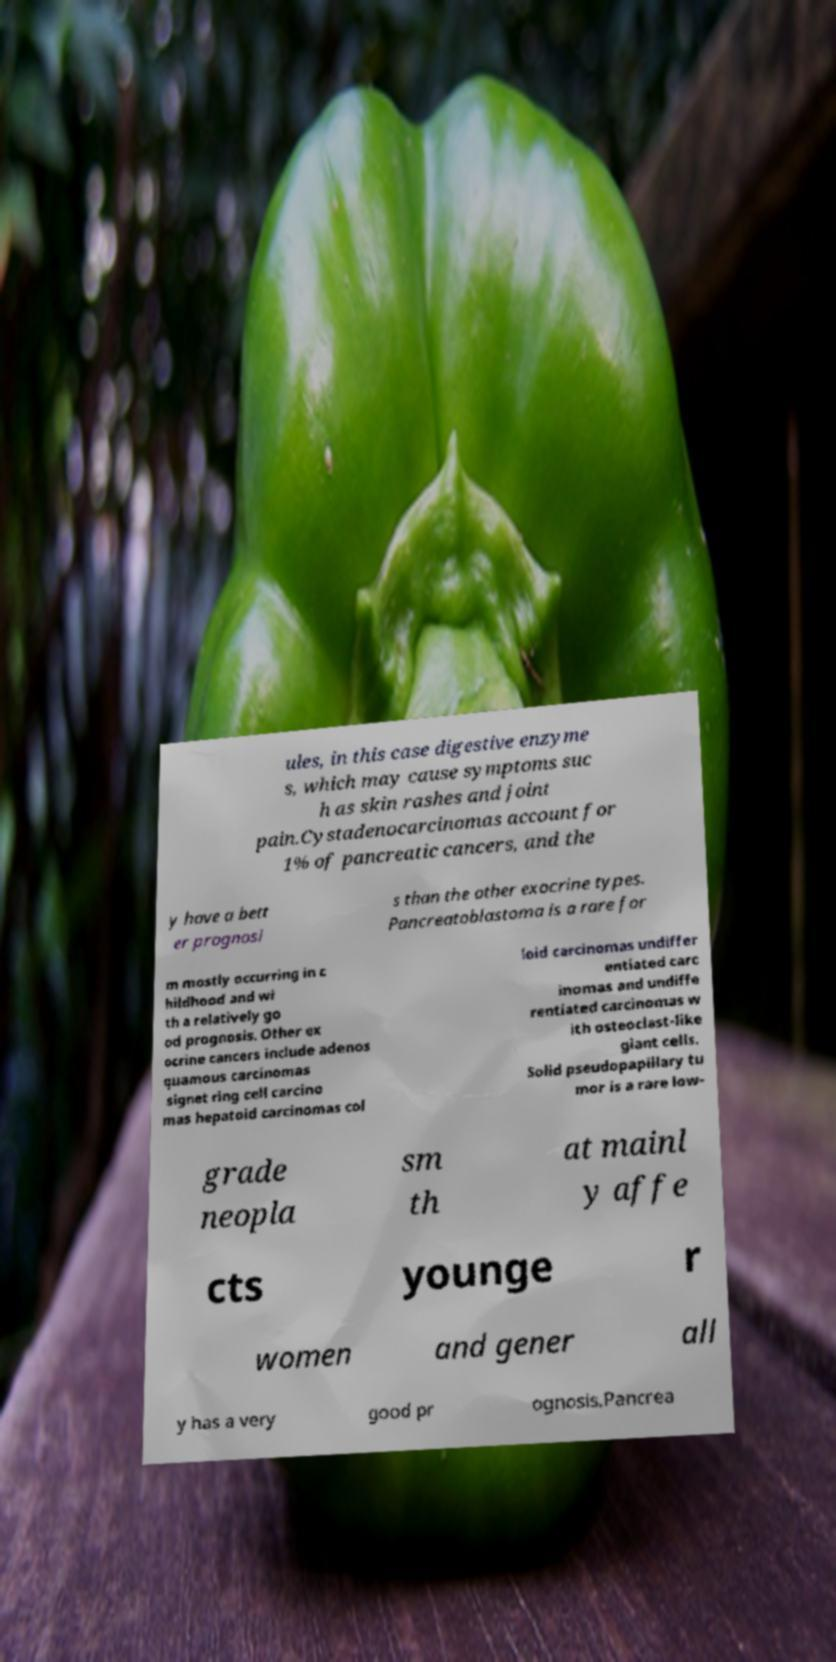Can you read and provide the text displayed in the image?This photo seems to have some interesting text. Can you extract and type it out for me? ules, in this case digestive enzyme s, which may cause symptoms suc h as skin rashes and joint pain.Cystadenocarcinomas account for 1% of pancreatic cancers, and the y have a bett er prognosi s than the other exocrine types. Pancreatoblastoma is a rare for m mostly occurring in c hildhood and wi th a relatively go od prognosis. Other ex ocrine cancers include adenos quamous carcinomas signet ring cell carcino mas hepatoid carcinomas col loid carcinomas undiffer entiated carc inomas and undiffe rentiated carcinomas w ith osteoclast-like giant cells. Solid pseudopapillary tu mor is a rare low- grade neopla sm th at mainl y affe cts younge r women and gener all y has a very good pr ognosis.Pancrea 